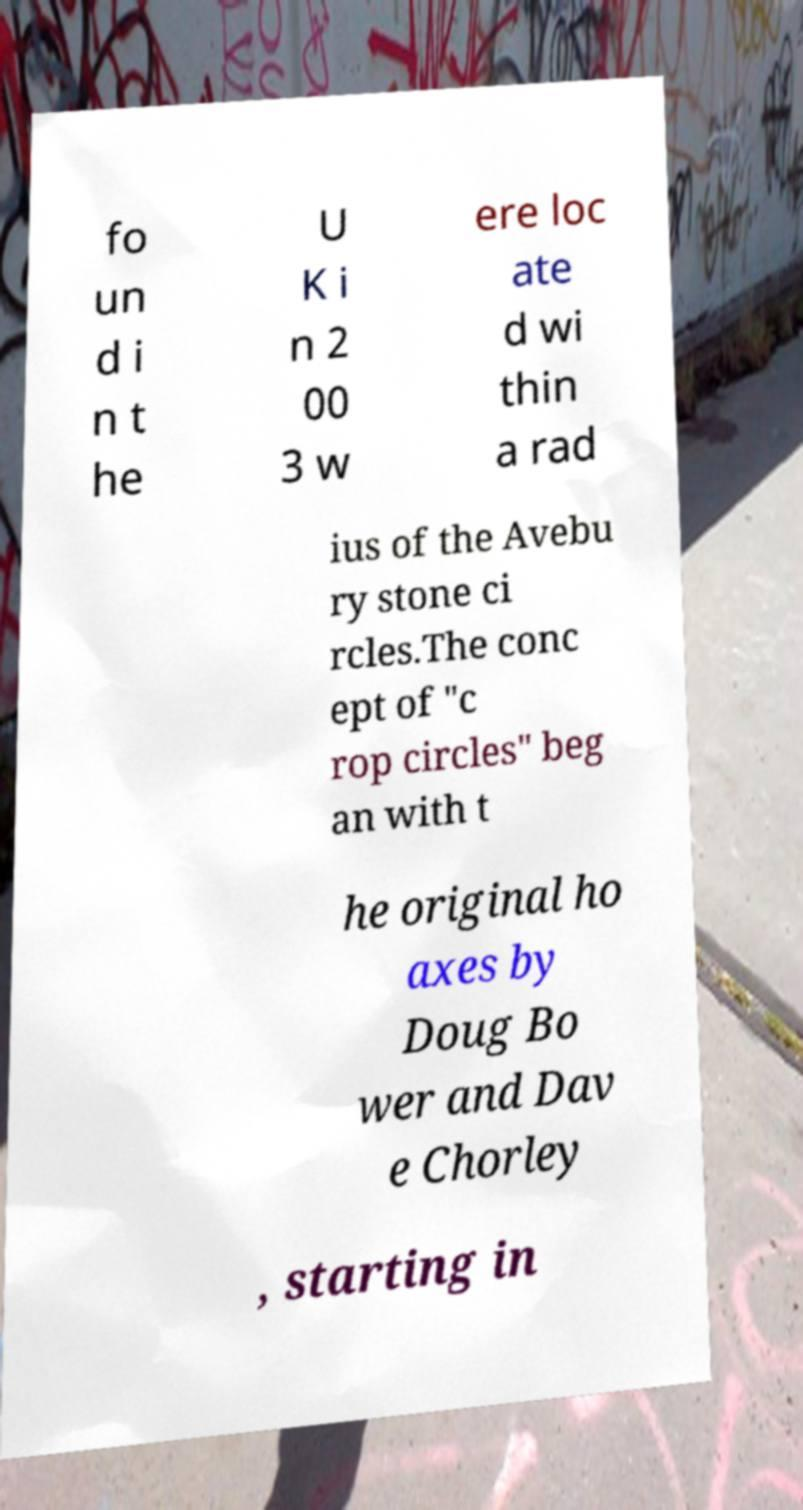Please read and relay the text visible in this image. What does it say? fo un d i n t he U K i n 2 00 3 w ere loc ate d wi thin a rad ius of the Avebu ry stone ci rcles.The conc ept of "c rop circles" beg an with t he original ho axes by Doug Bo wer and Dav e Chorley , starting in 